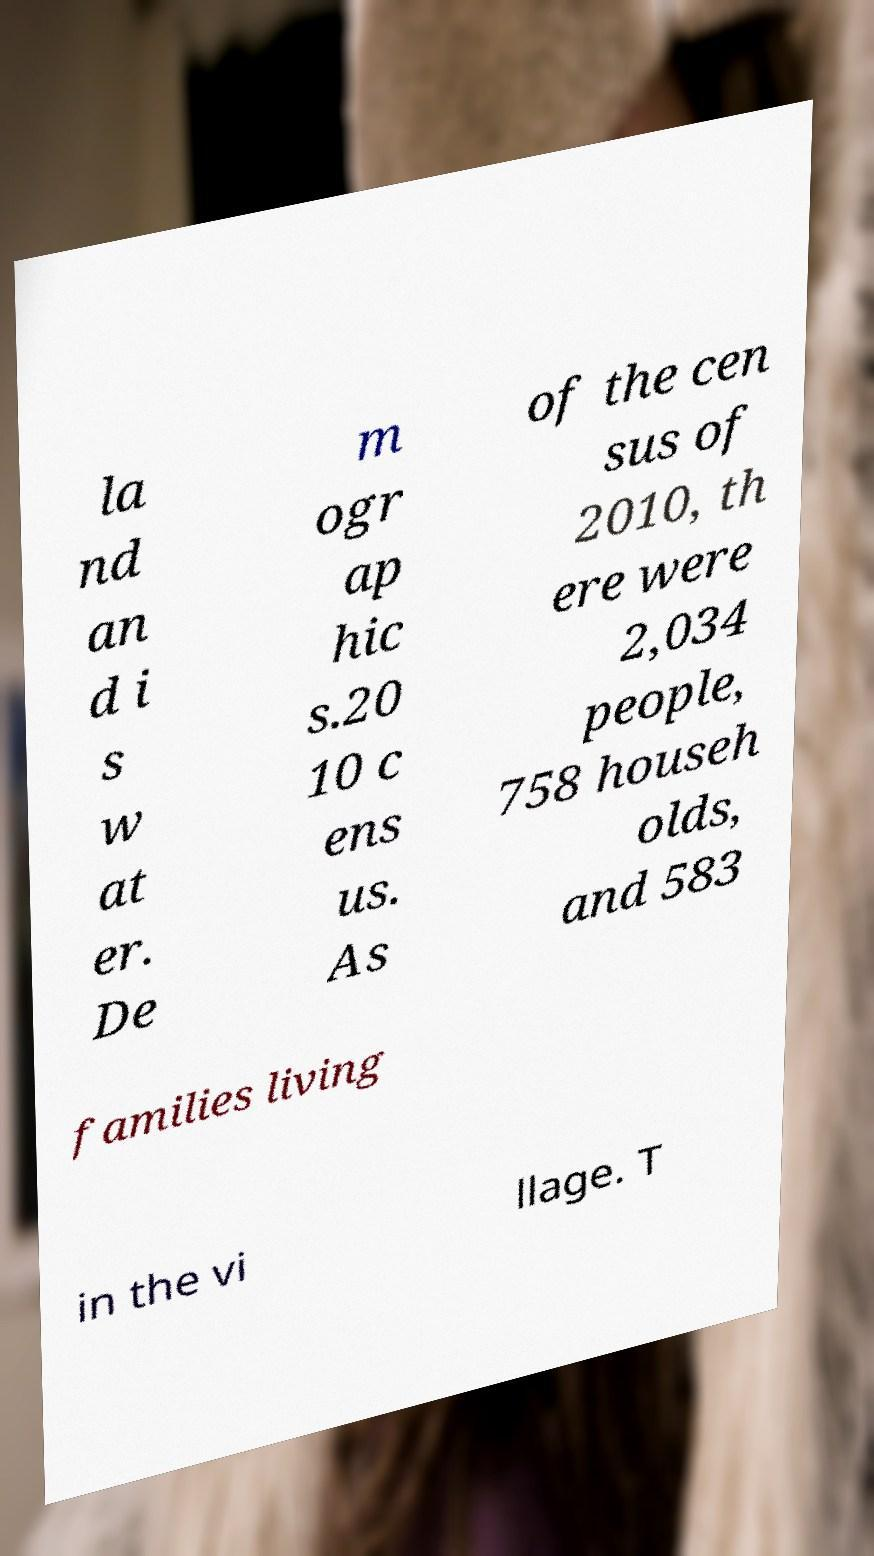Can you accurately transcribe the text from the provided image for me? la nd an d i s w at er. De m ogr ap hic s.20 10 c ens us. As of the cen sus of 2010, th ere were 2,034 people, 758 househ olds, and 583 families living in the vi llage. T 